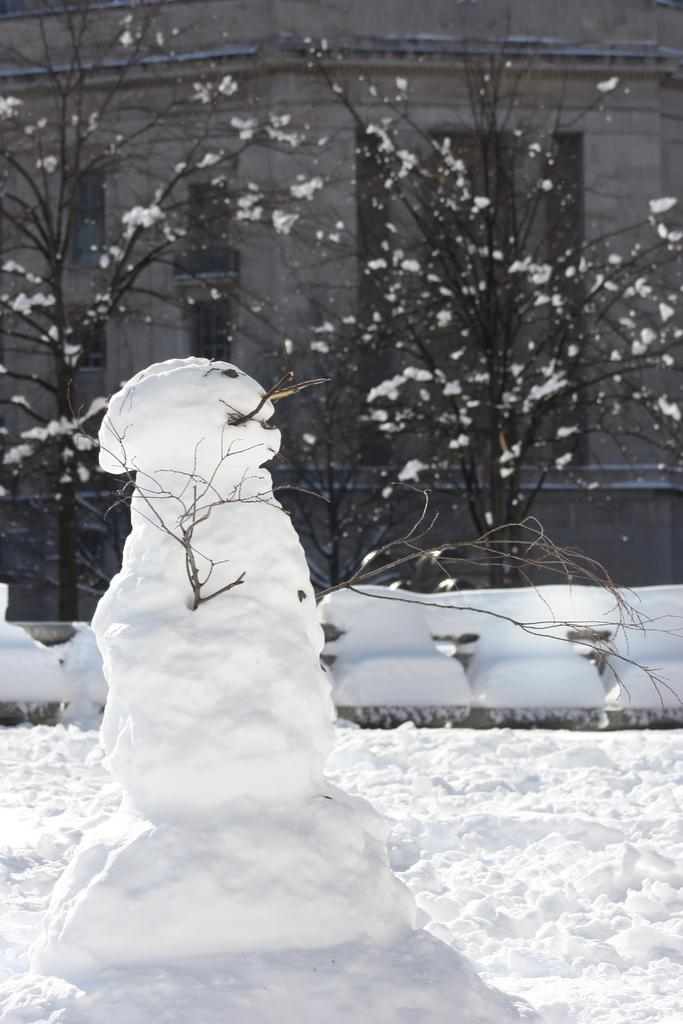What is the primary weather condition depicted in the image? There is snow in the image. What type of natural elements can be seen in the image? There are trees in the image. What type of structure is visible in the background of the image? There is a building with windows in the background of the image. What type of bubble can be seen floating in the image? There is no bubble present in the image. What list is visible in the image? There is no list present in the image. 